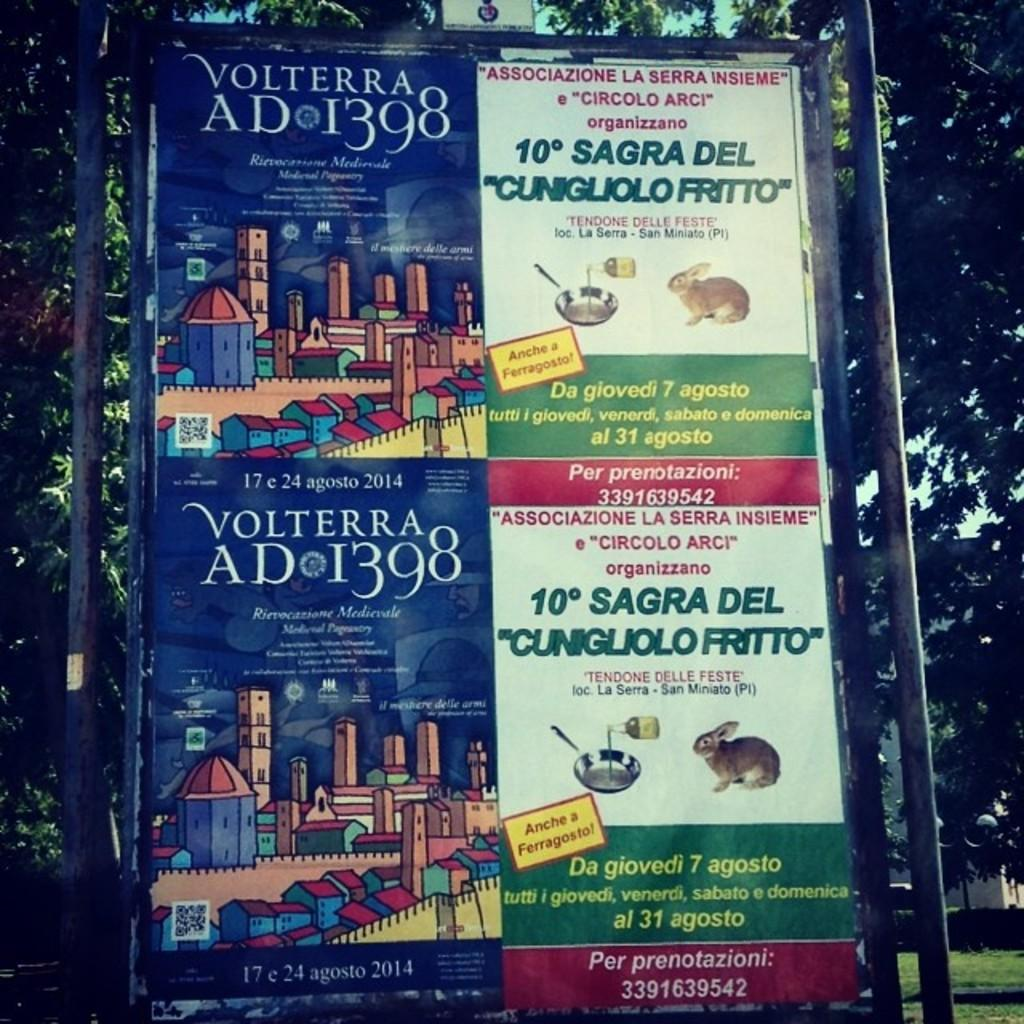<image>
Provide a brief description of the given image. Volterra Ad 1398 and 10 Sagra Del Cunguo Frito poster. 